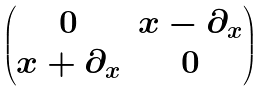Convert formula to latex. <formula><loc_0><loc_0><loc_500><loc_500>\begin{pmatrix} 0 & x - \partial _ { x } \\ x + \partial _ { x } & 0 \end{pmatrix}</formula> 